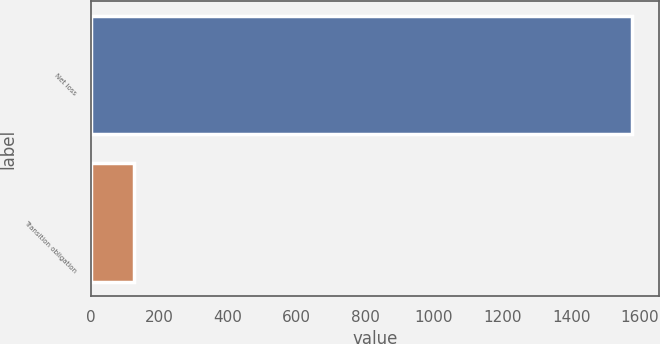<chart> <loc_0><loc_0><loc_500><loc_500><bar_chart><fcel>Net loss<fcel>Transition obligation<nl><fcel>1576<fcel>126<nl></chart> 